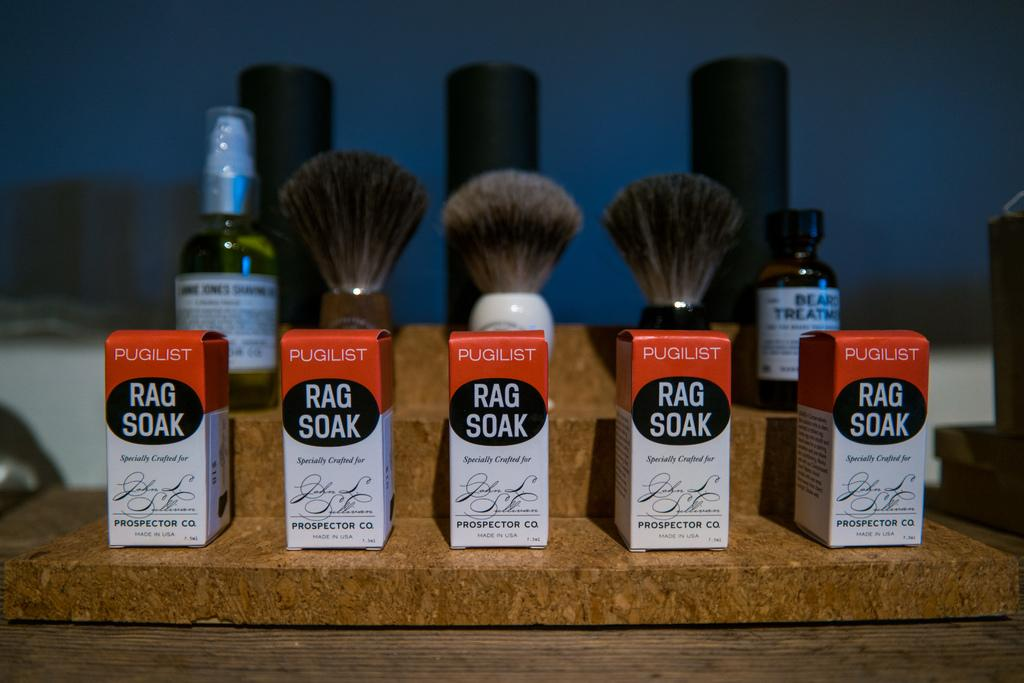<image>
Write a terse but informative summary of the picture. a group of makeup items called Rag Soaks 